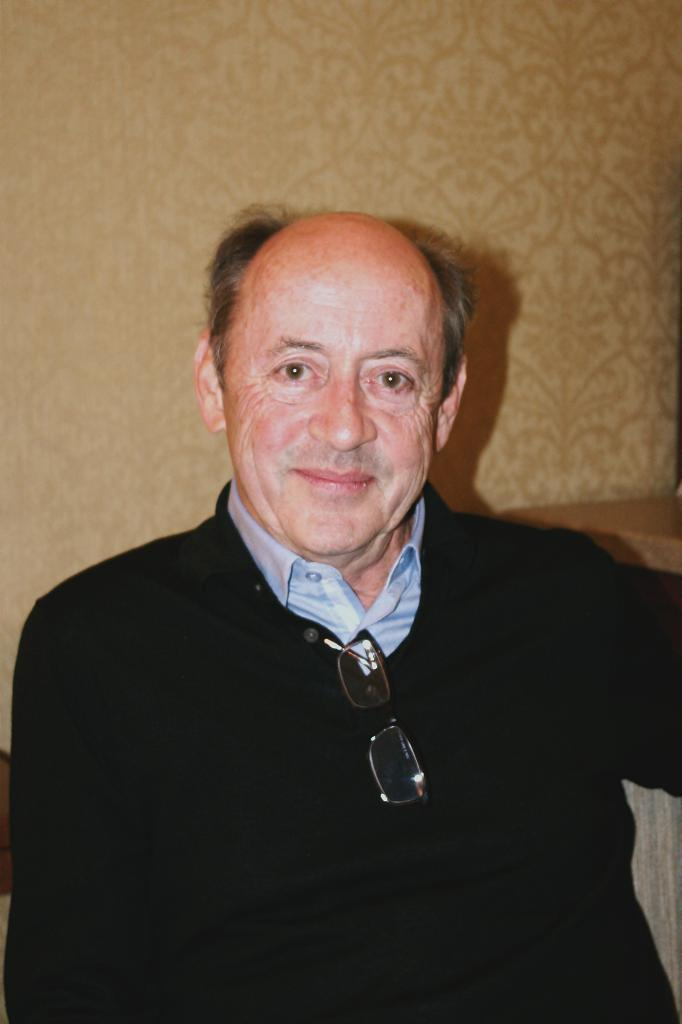Who is in the image? There is a man in the image. What is the man doing in the image? The man is posing for a photo. How is the man's facial expression in the image? The man is smiling in the image. What is attached to the man's coat? The man's spectacles are attached to his coat. What can be seen behind the man in the image? There is a wall behind the man. What sound does the bell make in the image? There is no bell present in the image. Can you describe the chicken in the image? There is no chicken present in the image. 